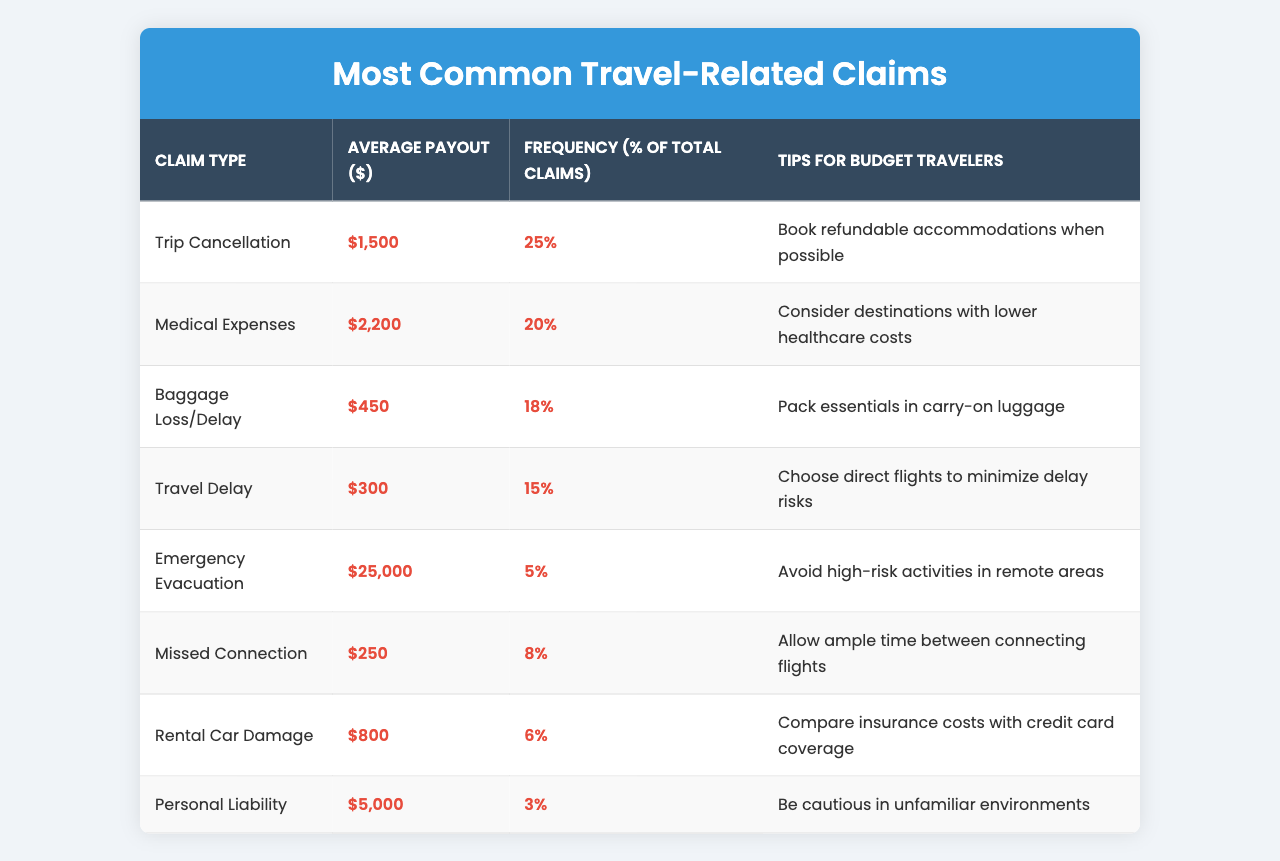What is the average payout for trip cancellation claims? The table indicates that the average payout for trip cancellation claims is $1,500.
Answer: $1,500 What percentage of total claims are for medical expenses? According to the table, medical expenses account for 20% of total claims.
Answer: 20% How much is the average payout for baggage loss or delay? The table shows that the average payout for baggage loss or delay is $450.
Answer: $450 What is the tip provided for budget travelers concerning missed connections? The table suggests allowing ample time between connecting flights as a tip for missed connections.
Answer: Allow ample time between connecting flights Which claim type has the highest average payout and what is it? The highest average payout is for emergency evacuation at $25,000, as shown in the table.
Answer: Emergency evacuation; $25,000 What is the average payout for personal liability claims? The average payout for personal liability claims is reported as $5,000 in the table.
Answer: $5,000 If you sum the average payouts for trip cancellation and medical expenses, what is the total? Adding $1,500 (trip cancellation) and $2,200 (medical expenses) gives a total of $3,700.
Answer: $3,700 What percentage of all claims are from baggage loss or delay? Baggage loss/delay claims account for 18% of total claims according to the table.
Answer: 18% Is it recommended to book refundable accommodations for budget travelers? Yes, the tips column suggests that travelers should book refundable accommodations when possible.
Answer: Yes If a traveler wanted to avoid high-risk activities to reduce potential claims, which claim type would they be focusing on? They would be focusing on emergency evacuation claims, as the advice relates to avoiding high-risk activities in remote areas.
Answer: Emergency evacuation How many claims account for 6% of total claims? Rental car damage claims are indicated to account for 6% of total claims in the table.
Answer: Rental car damage 